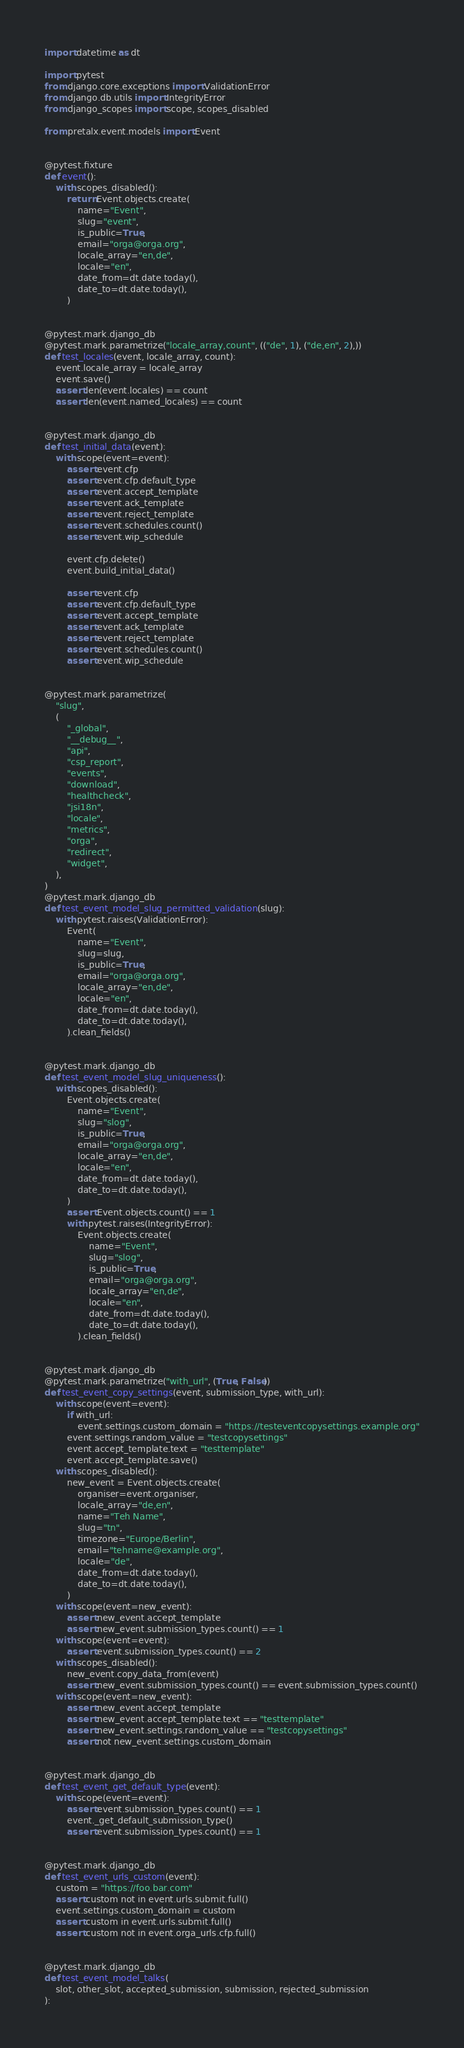<code> <loc_0><loc_0><loc_500><loc_500><_Python_>import datetime as dt

import pytest
from django.core.exceptions import ValidationError
from django.db.utils import IntegrityError
from django_scopes import scope, scopes_disabled

from pretalx.event.models import Event


@pytest.fixture
def event():
    with scopes_disabled():
        return Event.objects.create(
            name="Event",
            slug="event",
            is_public=True,
            email="orga@orga.org",
            locale_array="en,de",
            locale="en",
            date_from=dt.date.today(),
            date_to=dt.date.today(),
        )


@pytest.mark.django_db
@pytest.mark.parametrize("locale_array,count", (("de", 1), ("de,en", 2),))
def test_locales(event, locale_array, count):
    event.locale_array = locale_array
    event.save()
    assert len(event.locales) == count
    assert len(event.named_locales) == count


@pytest.mark.django_db
def test_initial_data(event):
    with scope(event=event):
        assert event.cfp
        assert event.cfp.default_type
        assert event.accept_template
        assert event.ack_template
        assert event.reject_template
        assert event.schedules.count()
        assert event.wip_schedule

        event.cfp.delete()
        event.build_initial_data()

        assert event.cfp
        assert event.cfp.default_type
        assert event.accept_template
        assert event.ack_template
        assert event.reject_template
        assert event.schedules.count()
        assert event.wip_schedule


@pytest.mark.parametrize(
    "slug",
    (
        "_global",
        "__debug__",
        "api",
        "csp_report",
        "events",
        "download",
        "healthcheck",
        "jsi18n",
        "locale",
        "metrics",
        "orga",
        "redirect",
        "widget",
    ),
)
@pytest.mark.django_db
def test_event_model_slug_permitted_validation(slug):
    with pytest.raises(ValidationError):
        Event(
            name="Event",
            slug=slug,
            is_public=True,
            email="orga@orga.org",
            locale_array="en,de",
            locale="en",
            date_from=dt.date.today(),
            date_to=dt.date.today(),
        ).clean_fields()


@pytest.mark.django_db
def test_event_model_slug_uniqueness():
    with scopes_disabled():
        Event.objects.create(
            name="Event",
            slug="slog",
            is_public=True,
            email="orga@orga.org",
            locale_array="en,de",
            locale="en",
            date_from=dt.date.today(),
            date_to=dt.date.today(),
        )
        assert Event.objects.count() == 1
        with pytest.raises(IntegrityError):
            Event.objects.create(
                name="Event",
                slug="slog",
                is_public=True,
                email="orga@orga.org",
                locale_array="en,de",
                locale="en",
                date_from=dt.date.today(),
                date_to=dt.date.today(),
            ).clean_fields()


@pytest.mark.django_db
@pytest.mark.parametrize("with_url", (True, False))
def test_event_copy_settings(event, submission_type, with_url):
    with scope(event=event):
        if with_url:
            event.settings.custom_domain = "https://testeventcopysettings.example.org"
        event.settings.random_value = "testcopysettings"
        event.accept_template.text = "testtemplate"
        event.accept_template.save()
    with scopes_disabled():
        new_event = Event.objects.create(
            organiser=event.organiser,
            locale_array="de,en",
            name="Teh Name",
            slug="tn",
            timezone="Europe/Berlin",
            email="tehname@example.org",
            locale="de",
            date_from=dt.date.today(),
            date_to=dt.date.today(),
        )
    with scope(event=new_event):
        assert new_event.accept_template
        assert new_event.submission_types.count() == 1
    with scope(event=event):
        assert event.submission_types.count() == 2
    with scopes_disabled():
        new_event.copy_data_from(event)
        assert new_event.submission_types.count() == event.submission_types.count()
    with scope(event=new_event):
        assert new_event.accept_template
        assert new_event.accept_template.text == "testtemplate"
        assert new_event.settings.random_value == "testcopysettings"
        assert not new_event.settings.custom_domain


@pytest.mark.django_db
def test_event_get_default_type(event):
    with scope(event=event):
        assert event.submission_types.count() == 1
        event._get_default_submission_type()
        assert event.submission_types.count() == 1


@pytest.mark.django_db
def test_event_urls_custom(event):
    custom = "https://foo.bar.com"
    assert custom not in event.urls.submit.full()
    event.settings.custom_domain = custom
    assert custom in event.urls.submit.full()
    assert custom not in event.orga_urls.cfp.full()


@pytest.mark.django_db
def test_event_model_talks(
    slot, other_slot, accepted_submission, submission, rejected_submission
):</code> 